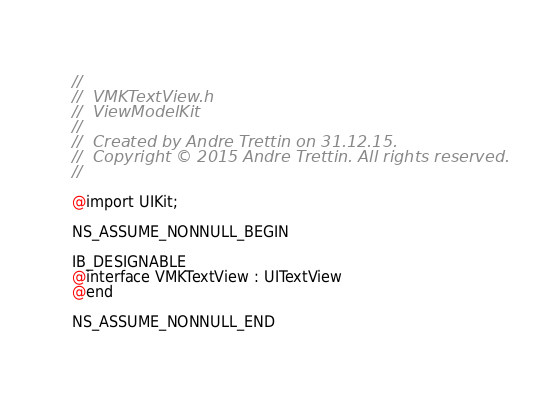<code> <loc_0><loc_0><loc_500><loc_500><_C_>//
//  VMKTextView.h
//  ViewModelKit
//
//  Created by Andre Trettin on 31.12.15.
//  Copyright © 2015 Andre Trettin. All rights reserved.
//

@import UIKit;

NS_ASSUME_NONNULL_BEGIN

IB_DESIGNABLE
@interface VMKTextView : UITextView
@end

NS_ASSUME_NONNULL_END
</code> 